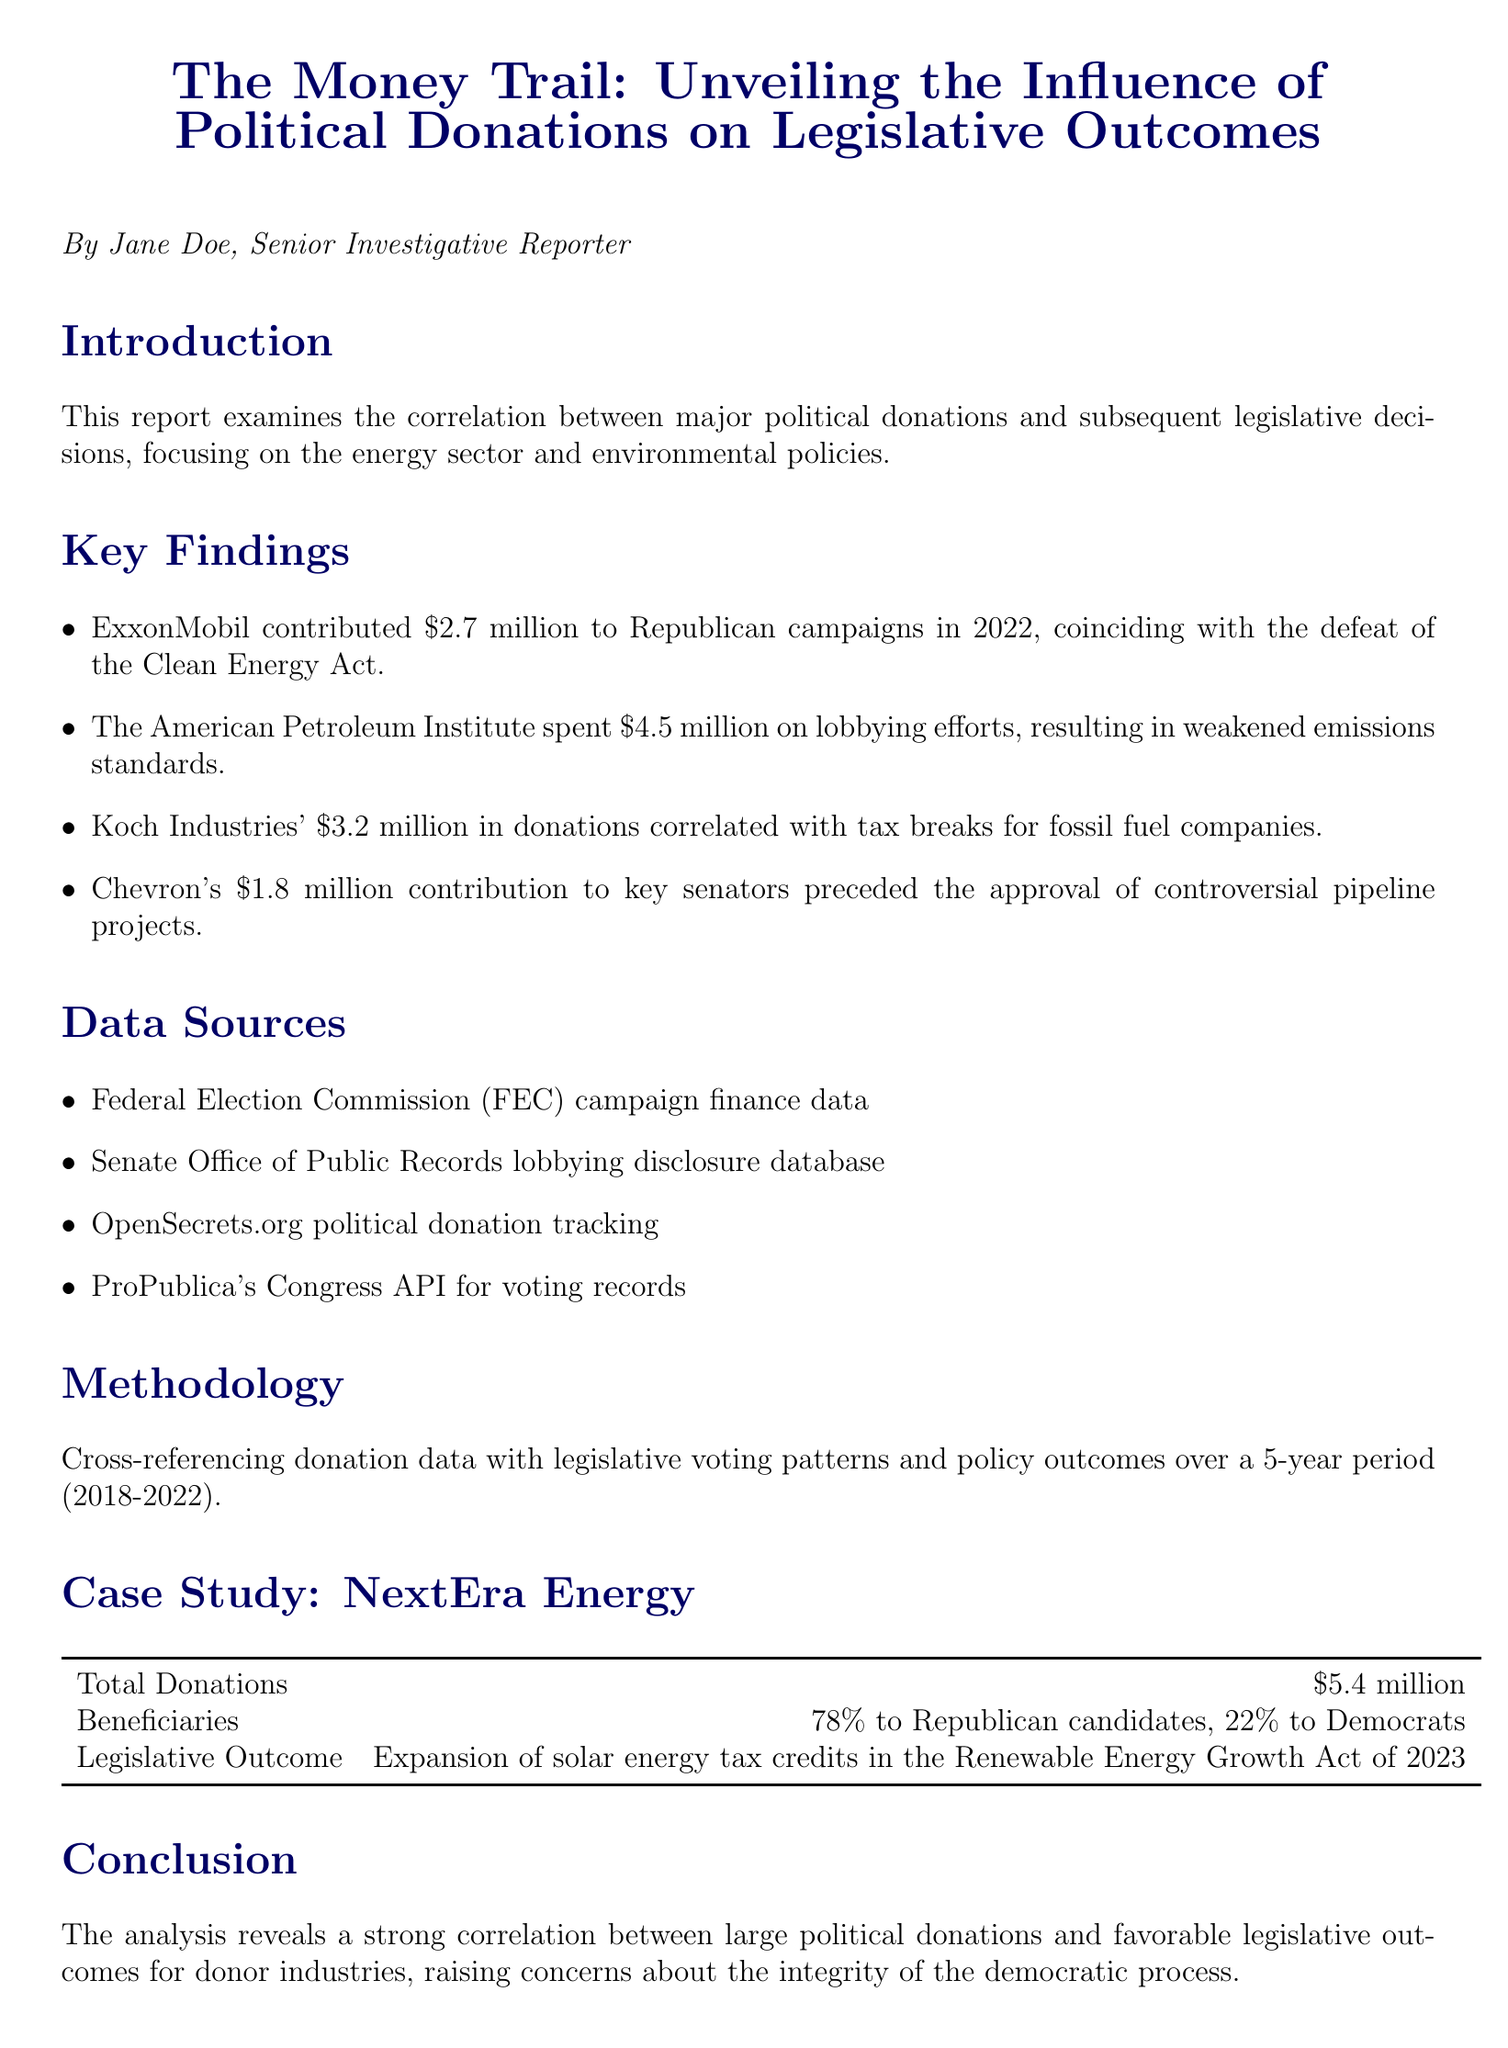What is the title of the report? The title is stated at the beginning of the document.
Answer: The Money Trail: Unveiling the Influence of Political Donations on Legislative Outcomes Who authored the report? The author name is mentioned right below the title.
Answer: Jane Doe, Senior Investigative Reporter How much did ExxonMobil contribute to Republican campaigns in 2022? This information is detailed in the key findings section of the document.
Answer: $2.7 million What percentage of NextEra Energy's total donations went to Republican candidates? This detail is found in the case study of NextEra Energy.
Answer: 78% What was the legislative outcome associated with Koch Industries' donations? The answer is inferred by correlating the donations made and the related legislative results mentioned.
Answer: Tax breaks for fossil fuel companies Which organization spent $4.5 million on lobbying efforts? This is specified in the key findings of the report.
Answer: The American Petroleum Institute What is the primary focus of the report? The introduction provides context on the report's emphasis.
Answer: The energy sector and environmental policies What does the report conclude? The conclusion summarizes the analysis of the donations and outcomes.
Answer: Strong correlation between large political donations and favorable legislative outcomes What are the recommendations for improving oversight in political donations? The recommendations section outlines suggested improvements.
Answer: Strengthen campaign finance laws 